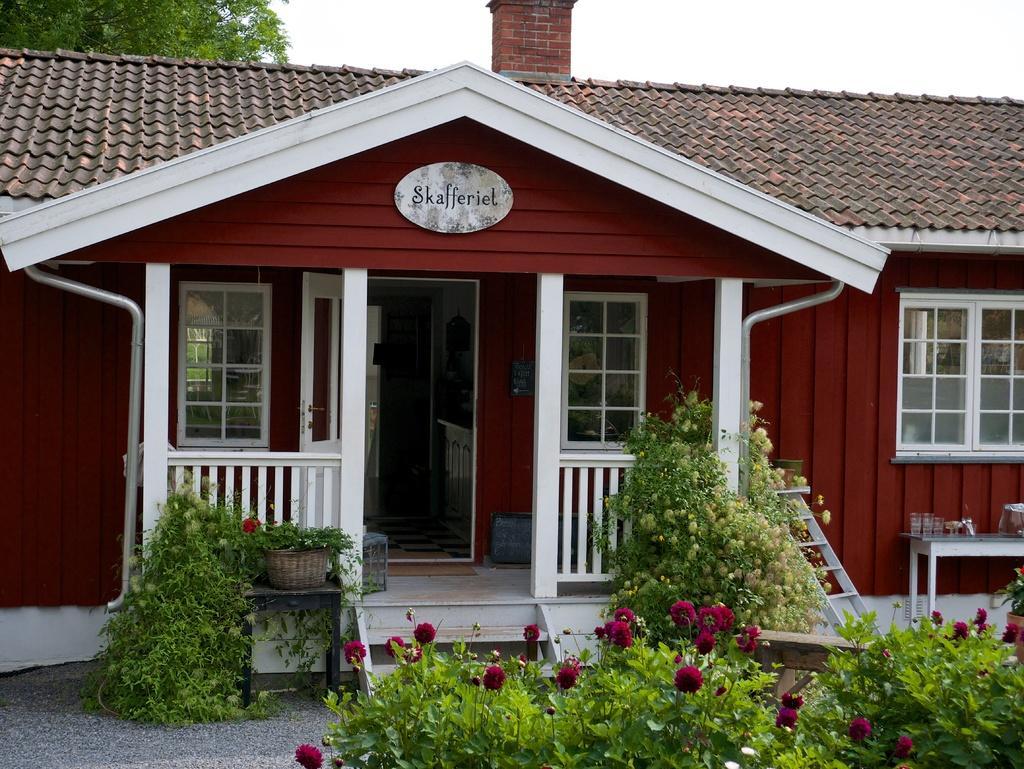Could you give a brief overview of what you see in this image? This is the front view of a house, we can see the porch, open door entrance, beside the door there are glass windows, in front of the porch there are stairs and there are flowers on the plants, behind the house there is a tree. 